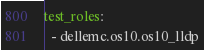<code> <loc_0><loc_0><loc_500><loc_500><_YAML_>test_roles:
  - dellemc.os10.os10_lldp
</code> 